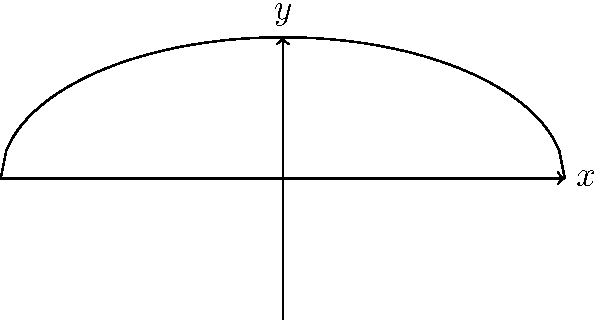As a football historian, you're interested in the mathematical properties of footballs. Consider a football modeled by rotating the curve $y = \sqrt{1 - \frac{x^2}{4}}$ around the x-axis from $x = -2$ to $x = 2$. Calculate the volume of this football using the method of integration by rotation. To find the volume of the football, we'll use the method of integration by rotation:

1) The formula for volume by rotation around the x-axis is:
   $$V = \pi \int_{a}^{b} [f(x)]^2 dx$$

2) In this case, $f(x) = \sqrt{1 - \frac{x^2}{4}}$, $a = -2$, and $b = 2$

3) Substituting into the formula:
   $$V = \pi \int_{-2}^{2} (1 - \frac{x^2}{4}) dx$$

4) Expand the integrand:
   $$V = \pi \int_{-2}^{2} (1 - \frac{x^2}{4}) dx$$

5) Integrate:
   $$V = \pi [x - \frac{x^3}{12}]_{-2}^{2}$$

6) Evaluate the definite integral:
   $$V = \pi [(2 - \frac{8}{12}) - (-2 - \frac{-8}{12})]$$

7) Simplify:
   $$V = \pi [(\frac{24}{12} - \frac{8}{12}) - (-\frac{24}{12} - \frac{-8}{12})]$$
   $$V = \pi [\frac{16}{12} + \frac{16}{12}]$$
   $$V = \pi [\frac{32}{12}]$$
   $$V = \frac{8\pi}{3}$$

Thus, the volume of the football is $\frac{8\pi}{3}$ cubic units.
Answer: $\frac{8\pi}{3}$ cubic units 